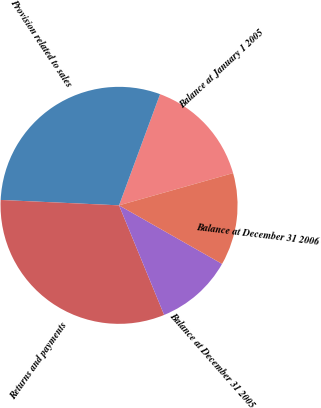Convert chart. <chart><loc_0><loc_0><loc_500><loc_500><pie_chart><fcel>Balance at January 1 2005<fcel>Provision related to sales<fcel>Returns and payments<fcel>Balance at December 31 2005<fcel>Balance at December 31 2006<nl><fcel>14.99%<fcel>29.9%<fcel>31.94%<fcel>10.56%<fcel>12.61%<nl></chart> 